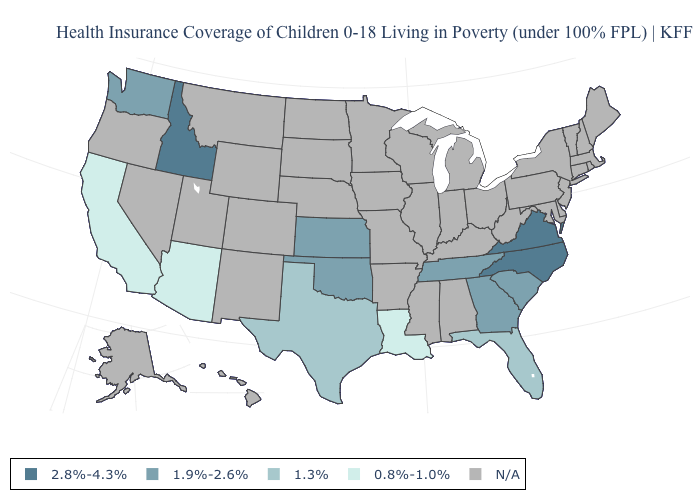Does the first symbol in the legend represent the smallest category?
Be succinct. No. Name the states that have a value in the range 1.3%?
Give a very brief answer. Florida, Texas. Name the states that have a value in the range 2.8%-4.3%?
Give a very brief answer. Idaho, North Carolina, Virginia. Which states have the lowest value in the USA?
Be succinct. Arizona, California, Louisiana. What is the value of Nevada?
Write a very short answer. N/A. What is the lowest value in the USA?
Be succinct. 0.8%-1.0%. Which states have the lowest value in the USA?
Be succinct. Arizona, California, Louisiana. Is the legend a continuous bar?
Keep it brief. No. Name the states that have a value in the range 1.3%?
Quick response, please. Florida, Texas. What is the value of Delaware?
Quick response, please. N/A. Does Tennessee have the lowest value in the South?
Short answer required. No. Among the states that border Georgia , does North Carolina have the highest value?
Give a very brief answer. Yes. 